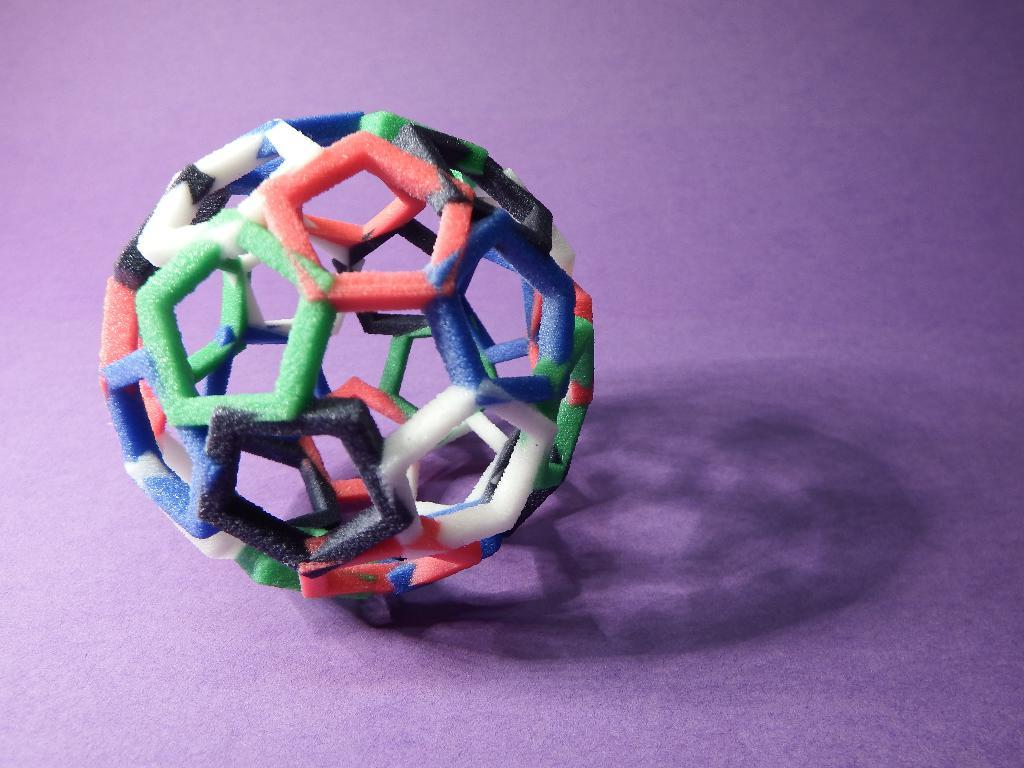What shape is the ball in the image? The ball in the image is pentagonal. Can you describe the ball's location in the image? The pentagonal ball is present on a surface. How does the ball shake in the image? The ball does not shake in the image; it is stationary on the surface. 